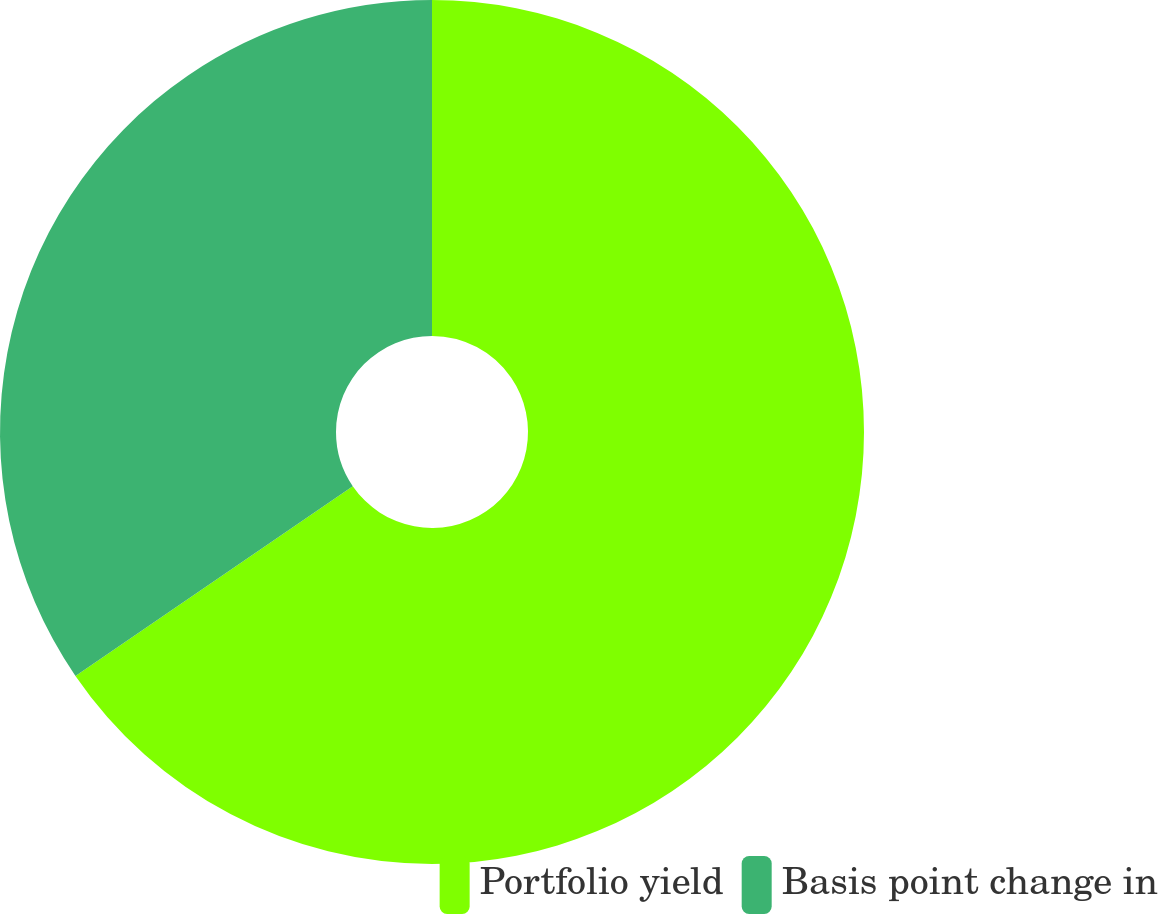Convert chart to OTSL. <chart><loc_0><loc_0><loc_500><loc_500><pie_chart><fcel>Portfolio yield<fcel>Basis point change in<nl><fcel>65.45%<fcel>34.55%<nl></chart> 